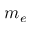<formula> <loc_0><loc_0><loc_500><loc_500>m _ { e }</formula> 